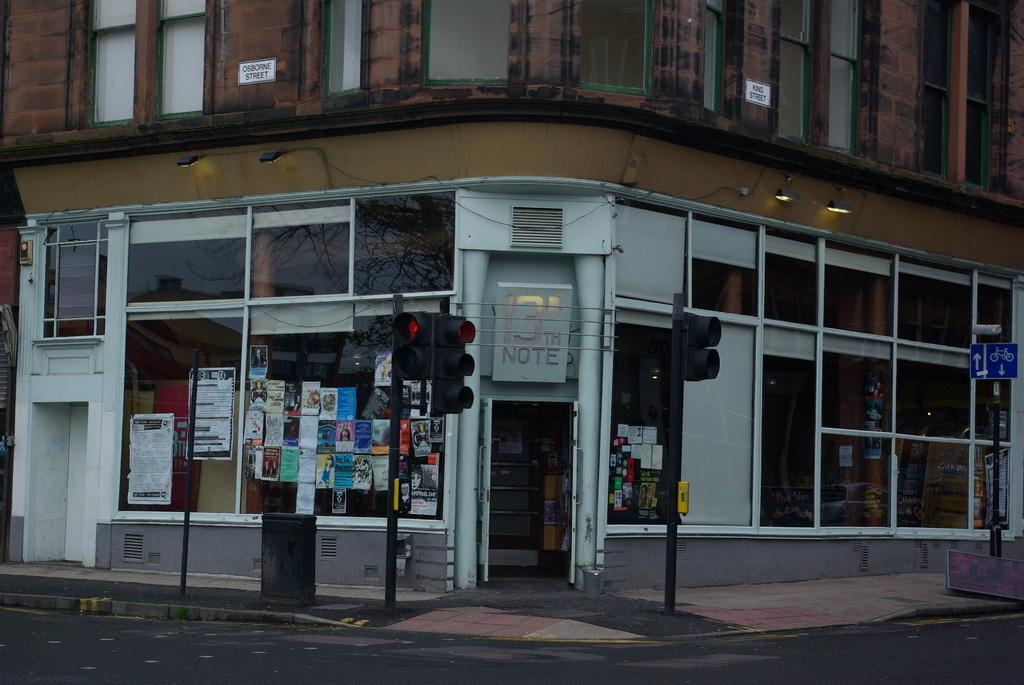What type of building is depicted in the image? There is a building with glass windows and walls in the image. What can be seen on the walls or windows of the building? There are posters in the image. What is present near the building to provide information or directions? There is a sign board in the image. What are the vertical structures in the image used for? There are poles in the image, which may be used for various purposes such as lighting or signage. What is used to control traffic in the image? There are traffic signals in the image. What is visible at the bottom of the image? There is a road and a footpath at the bottom of the image. What type of can is shown growing on the building in the image? There is no can or any type of plant growing on the building in the image. What is the weather like in the image, with sleet visible on the ground? There is no mention of weather or sleet in the image; it only shows a building, posters, sign board, poles, traffic signals, road, and footpath. 